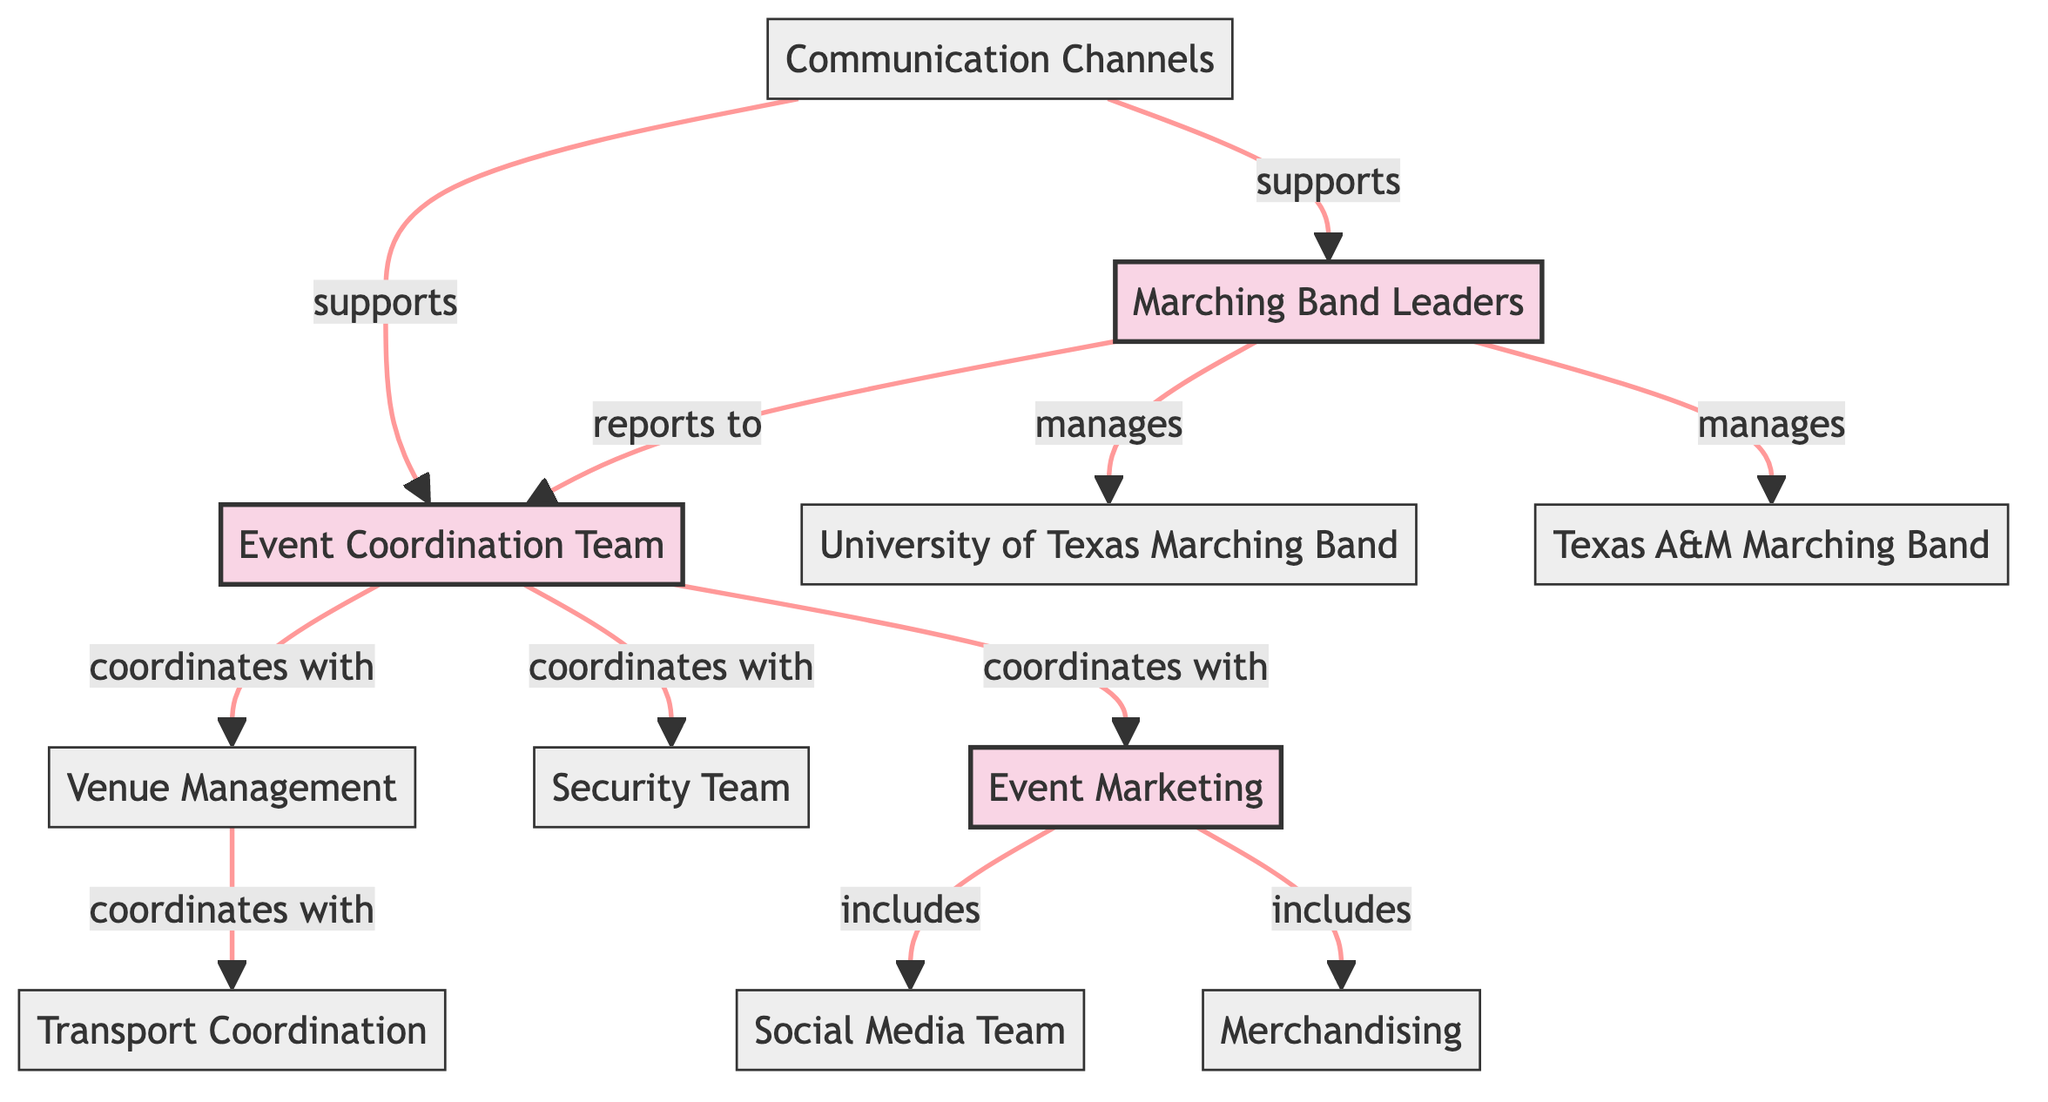What is the total number of nodes in the diagram? The diagram contains a total of 11 nodes, which represent different groups and entities involved in the event planning and logistics.
Answer: 11 Which team does the Marching Band Leaders manage? The Marching Band Leaders manage both the University of Texas Marching Band and the Texas A&M Marching Band as indicated by the "manages" relationship in the edges.
Answer: University of Texas Marching Band, Texas A&M Marching Band What types of entities are included in the "Event Marketing" group? Event Marketing includes the Social Media Team and Merchandising. This is represented by the "includes" relationships connecting these entities to the Event Marketing group.
Answer: Social Media Team, Merchandising Who does the Event Coordination Team coordinate with? The Event Coordination Team coordinates with Venue Management, Security Team, and Event Marketing, illustrated by three separate "coordinates with" relationships in the edges.
Answer: Venue Management, Security Team, Event Marketing Which group reports to the Event Coordination Team? The Marching Band Leaders report to the Event Coordination Team, as indicated by the "reports to" relationship connecting these two nodes.
Answer: Marching Band Leaders How many entities support the Event Coordination Team? The Communication Channels support the Event Coordination Team, as indicated by the "supports" relationship shown in the edges. This is the only support shown in the diagram.
Answer: 1 What is the primary role of the nodes classified as "group"? The primary role of the nodes classified as "group" is to coordinate and manage the overall planning and logistics of the event. In the diagram, the Event Coordination Team and Marching Band Leaders fall under this category.
Answer: Coordinate and manage Which entity coordinates with Transport Coordination? Venue Management coordinates with Transport Coordination, as indicated by the "coordinates with" relationship present in the diagram edges.
Answer: Venue Management 